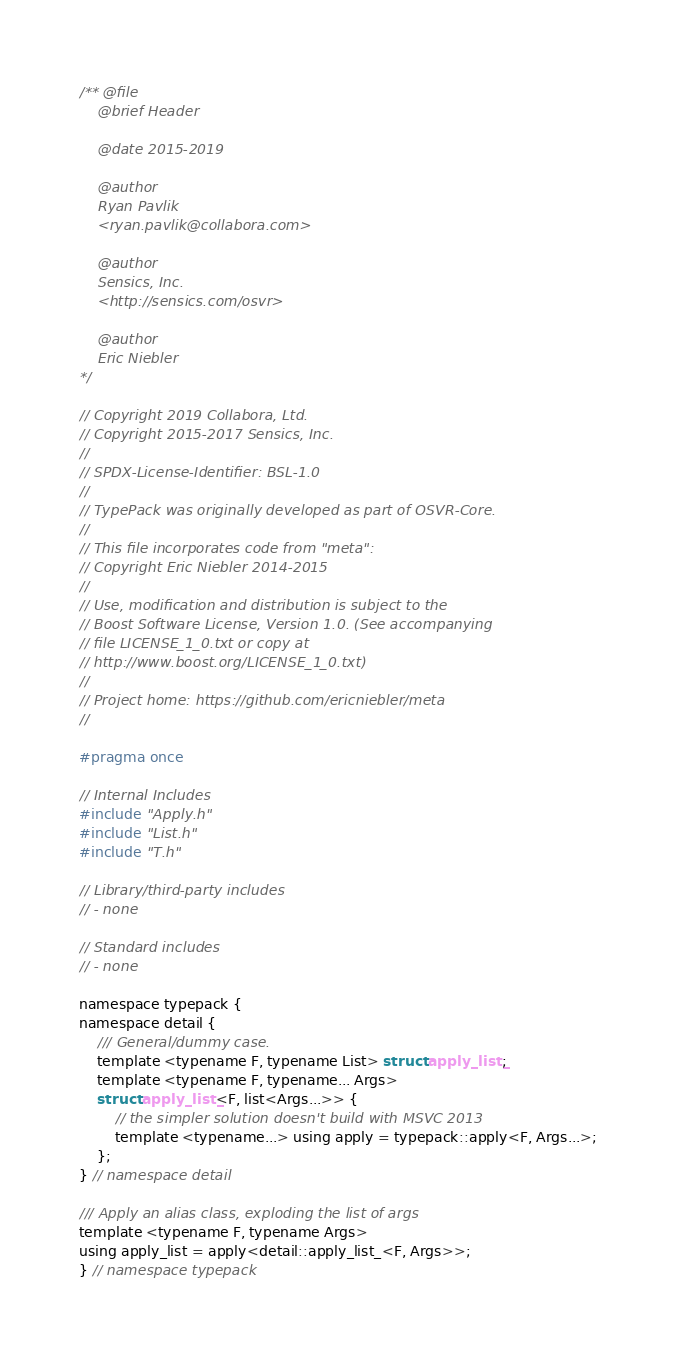<code> <loc_0><loc_0><loc_500><loc_500><_C_>/** @file
    @brief Header

    @date 2015-2019

    @author
    Ryan Pavlik
    <ryan.pavlik@collabora.com>

    @author
    Sensics, Inc.
    <http://sensics.com/osvr>

    @author
    Eric Niebler
*/

// Copyright 2019 Collabora, Ltd.
// Copyright 2015-2017 Sensics, Inc.
//
// SPDX-License-Identifier: BSL-1.0
//
// TypePack was originally developed as part of OSVR-Core.
//
// This file incorporates code from "meta":
// Copyright Eric Niebler 2014-2015
//
// Use, modification and distribution is subject to the
// Boost Software License, Version 1.0. (See accompanying
// file LICENSE_1_0.txt or copy at
// http://www.boost.org/LICENSE_1_0.txt)
//
// Project home: https://github.com/ericniebler/meta
//

#pragma once

// Internal Includes
#include "Apply.h"
#include "List.h"
#include "T.h"

// Library/third-party includes
// - none

// Standard includes
// - none

namespace typepack {
namespace detail {
    /// General/dummy case.
    template <typename F, typename List> struct apply_list_;
    template <typename F, typename... Args>
    struct apply_list_<F, list<Args...>> {
        // the simpler solution doesn't build with MSVC 2013
        template <typename...> using apply = typepack::apply<F, Args...>;
    };
} // namespace detail

/// Apply an alias class, exploding the list of args
template <typename F, typename Args>
using apply_list = apply<detail::apply_list_<F, Args>>;
} // namespace typepack
</code> 